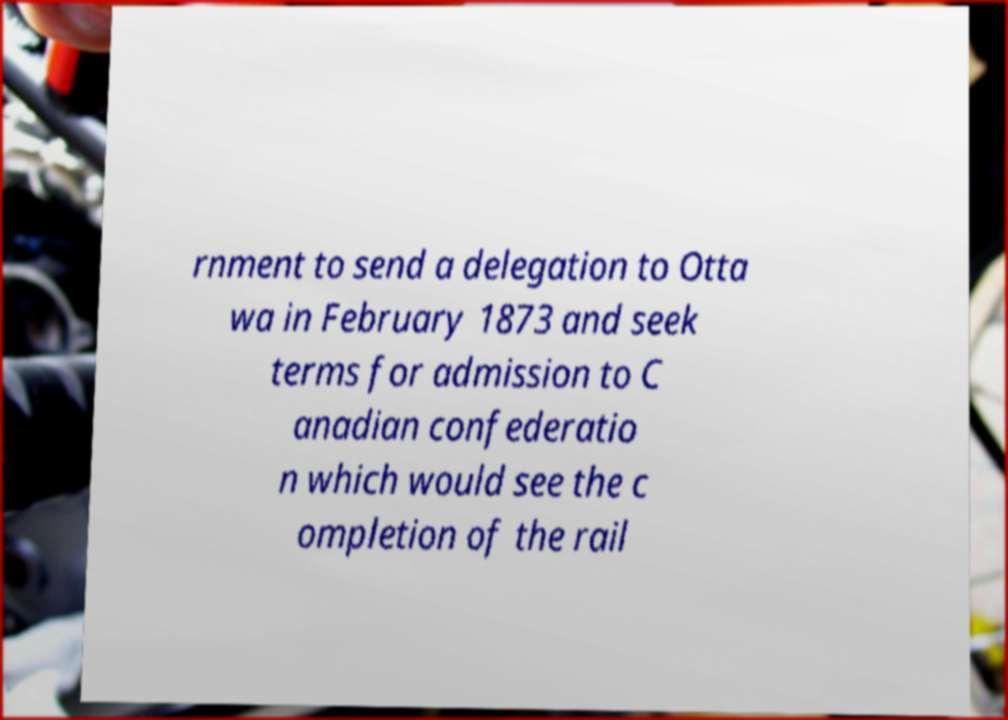I need the written content from this picture converted into text. Can you do that? rnment to send a delegation to Otta wa in February 1873 and seek terms for admission to C anadian confederatio n which would see the c ompletion of the rail 